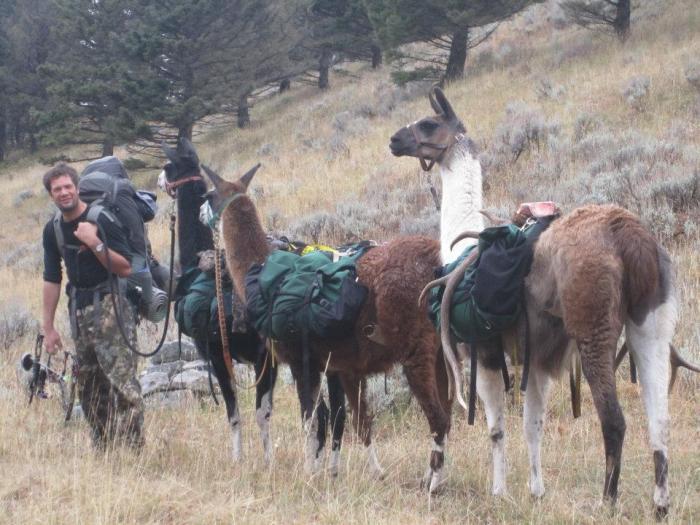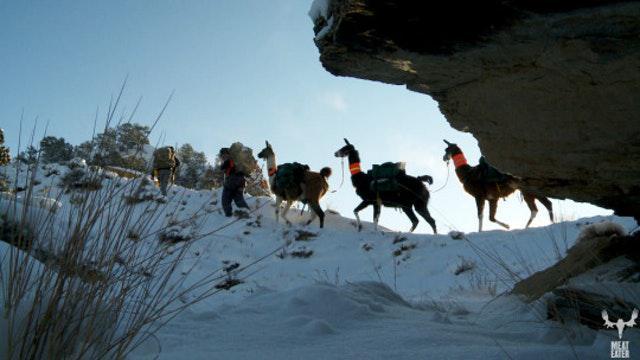The first image is the image on the left, the second image is the image on the right. Considering the images on both sides, is "The left image contains a single llama and a single person." valid? Answer yes or no. No. The first image is the image on the left, the second image is the image on the right. For the images displayed, is the sentence "The left and right image contains the same number of llamas." factually correct? Answer yes or no. Yes. 